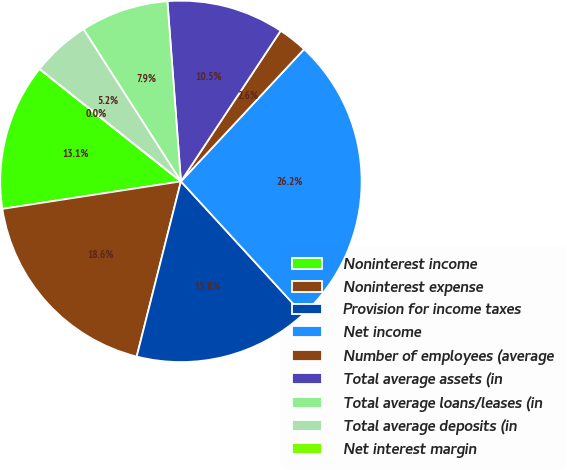Convert chart to OTSL. <chart><loc_0><loc_0><loc_500><loc_500><pie_chart><fcel>Noninterest income<fcel>Noninterest expense<fcel>Provision for income taxes<fcel>Net income<fcel>Number of employees (average<fcel>Total average assets (in<fcel>Total average loans/leases (in<fcel>Total average deposits (in<fcel>Net interest margin<nl><fcel>13.12%<fcel>18.63%<fcel>15.75%<fcel>26.25%<fcel>2.63%<fcel>10.5%<fcel>7.87%<fcel>5.25%<fcel>0.0%<nl></chart> 